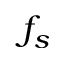Convert formula to latex. <formula><loc_0><loc_0><loc_500><loc_500>f _ { s }</formula> 